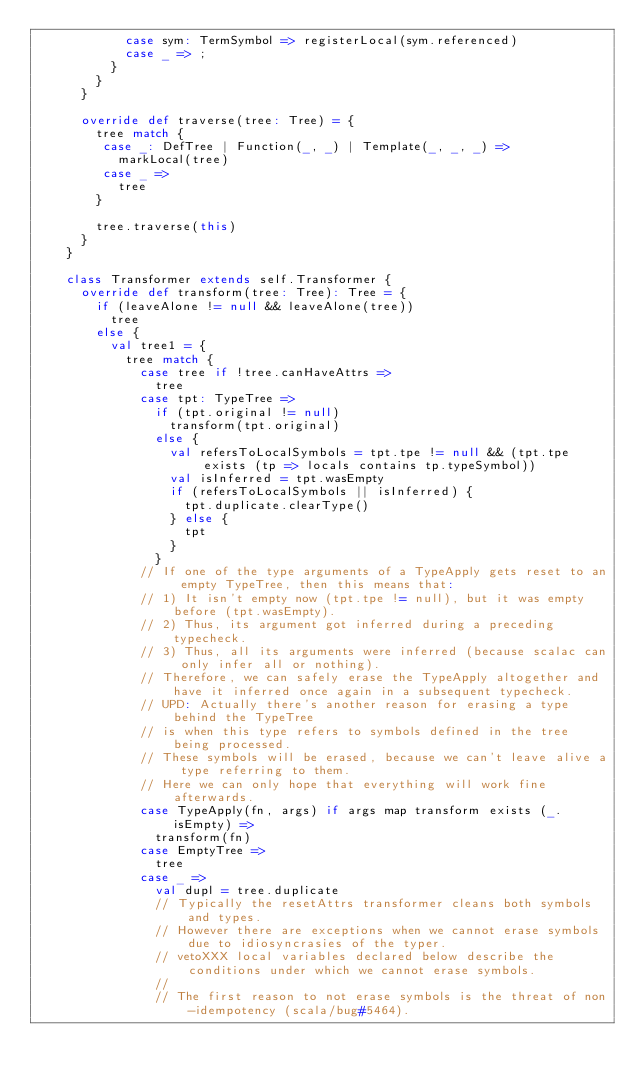Convert code to text. <code><loc_0><loc_0><loc_500><loc_500><_Scala_>            case sym: TermSymbol => registerLocal(sym.referenced)
            case _ => ;
          }
        }
      }

      override def traverse(tree: Tree) = {
        tree match {
         case _: DefTree | Function(_, _) | Template(_, _, _) =>
           markLocal(tree)
         case _ =>
           tree
        }

        tree.traverse(this)
      }
    }

    class Transformer extends self.Transformer {
      override def transform(tree: Tree): Tree = {
        if (leaveAlone != null && leaveAlone(tree))
          tree
        else {
          val tree1 = {
            tree match {
              case tree if !tree.canHaveAttrs =>
                tree
              case tpt: TypeTree =>
                if (tpt.original != null)
                  transform(tpt.original)
                else {
                  val refersToLocalSymbols = tpt.tpe != null && (tpt.tpe exists (tp => locals contains tp.typeSymbol))
                  val isInferred = tpt.wasEmpty
                  if (refersToLocalSymbols || isInferred) {
                    tpt.duplicate.clearType()
                  } else {
                    tpt
                  }
                }
              // If one of the type arguments of a TypeApply gets reset to an empty TypeTree, then this means that:
              // 1) It isn't empty now (tpt.tpe != null), but it was empty before (tpt.wasEmpty).
              // 2) Thus, its argument got inferred during a preceding typecheck.
              // 3) Thus, all its arguments were inferred (because scalac can only infer all or nothing).
              // Therefore, we can safely erase the TypeApply altogether and have it inferred once again in a subsequent typecheck.
              // UPD: Actually there's another reason for erasing a type behind the TypeTree
              // is when this type refers to symbols defined in the tree being processed.
              // These symbols will be erased, because we can't leave alive a type referring to them.
              // Here we can only hope that everything will work fine afterwards.
              case TypeApply(fn, args) if args map transform exists (_.isEmpty) =>
                transform(fn)
              case EmptyTree =>
                tree
              case _ =>
                val dupl = tree.duplicate
                // Typically the resetAttrs transformer cleans both symbols and types.
                // However there are exceptions when we cannot erase symbols due to idiosyncrasies of the typer.
                // vetoXXX local variables declared below describe the conditions under which we cannot erase symbols.
                //
                // The first reason to not erase symbols is the threat of non-idempotency (scala/bug#5464).</code> 